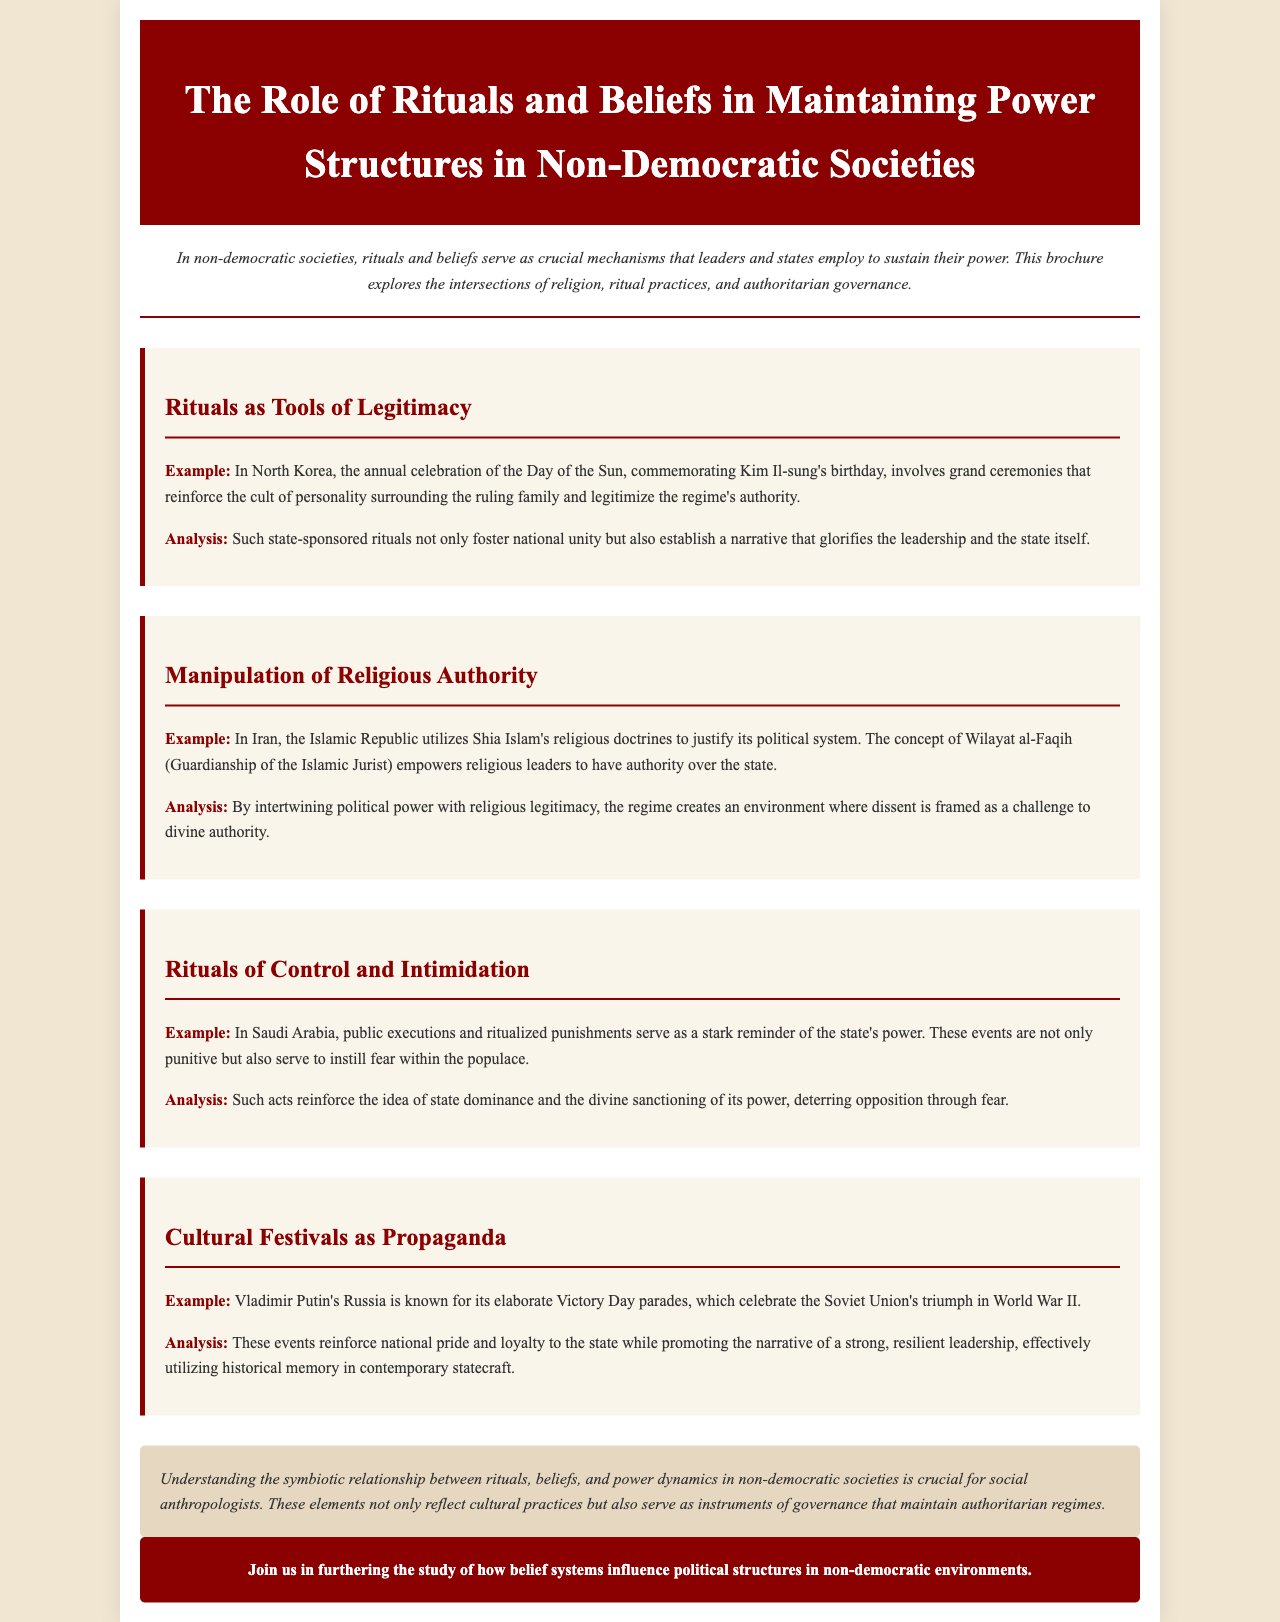What is the title of the brochure? The title is specified in the header of the document.
Answer: The Role of Rituals and Beliefs in Maintaining Power Structures in Non-Democratic Societies What annual celebration is mentioned in North Korea? The example given highlights a specific event related to leadership legitimacy.
Answer: Day of the Sun What doctrine does the Iranian regime use to justify its political system? This doctrine is central to the regime's authority and is mentioned in the context of religious authority.
Answer: Wilayat al-Faqih What type of punishments are carried out in Saudi Arabia? The document provides an example of a specific practice used for control.
Answer: Public executions What significant historical event does Putin's Russia commemorate with parades? The example highlights a specific historical event used for state propaganda.
Answer: World War II How do public executions serve the state? The analysis explains the purpose behind certain rituals in maintaining power.
Answer: Instill fear What is identified as a primary purpose of cultural festivals in non-democratic societies? The analysis within the document summarizes the role of these festivals.
Answer: Propaganda What critical relationship is highlighted in the conclusion? The conclusion summarizes the interactions mentioned throughout the brochure.
Answer: Rituals, beliefs, and power dynamics 